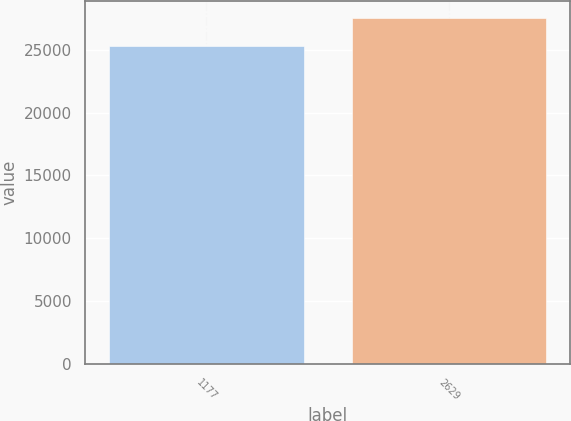Convert chart to OTSL. <chart><loc_0><loc_0><loc_500><loc_500><bar_chart><fcel>1177<fcel>2629<nl><fcel>25253<fcel>27498<nl></chart> 